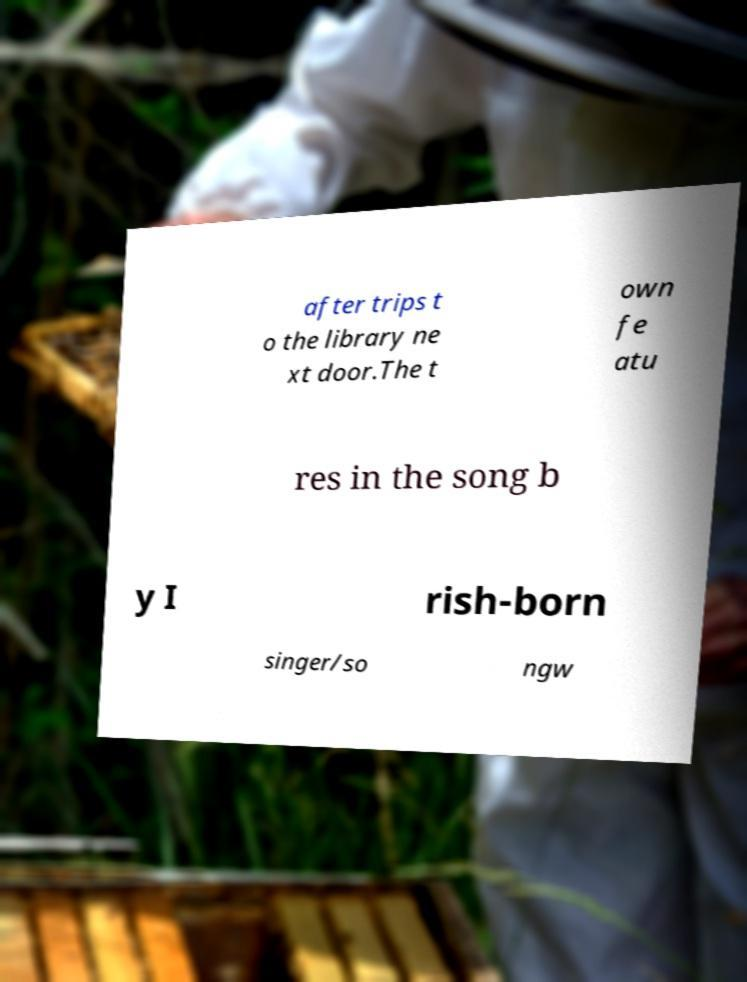I need the written content from this picture converted into text. Can you do that? after trips t o the library ne xt door.The t own fe atu res in the song b y I rish-born singer/so ngw 